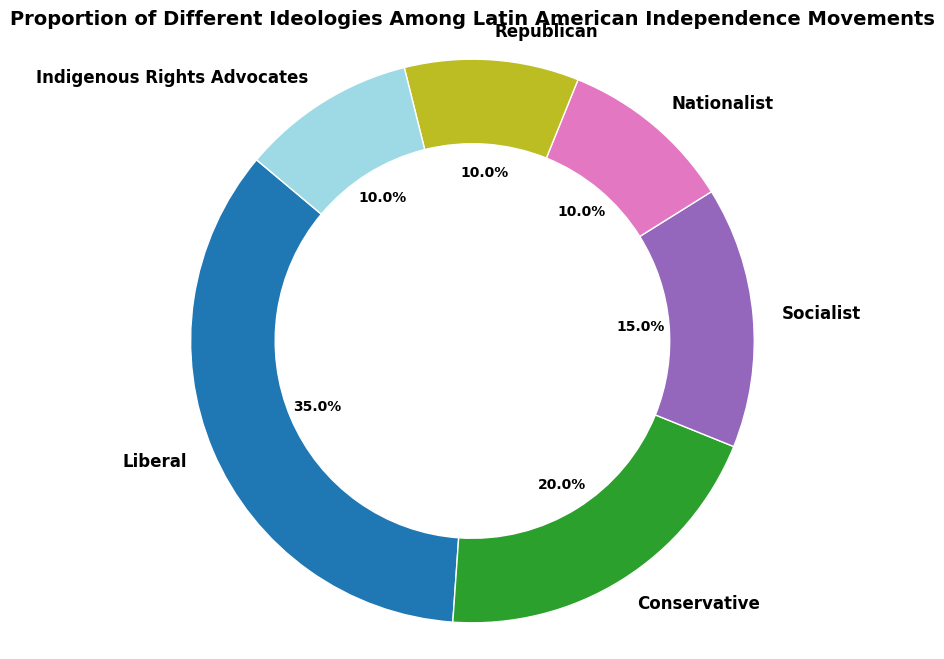What proportion of the ideologies is represented by the Republican and Indigenous Rights Advocates together? Sum the percentages of Republican (10%) and Indigenous Rights Advocates (10%): 10 + 10 = 20
Answer: 20% Which ideology has the largest proportion? The chart shows that the Liberal ideology has the largest slice, labeled as 35%.
Answer: Liberal How does the proportion of Socialists compare to that of Nationalists? The pie chart shows Socialists at 15% and Nationalists at 10%. Therefore, Socialists have a greater proportion.
Answer: Socialists have a greater proportion What is the proportion difference between the highest and the lowest represented ideologies? The highest proportion is Liberal at 35% and the lowest is Nationalist, Republican and Indigenous Rights Advocates each at 10%. The difference is 35 - 10 = 25.
Answer: 25% What are the combined proportions of Liberal, Conservative, and Socialist ideologies? Sum the percentages: Liberal (35%) + Conservative (20%) + Socialist (15%) = 35 + 20 + 15 = 70
Answer: 70% Is the proportion of Nationalists greater than that of Republicans? The pie chart shows both Nationalists and Republicans at 10%. So, neither is greater.
Answer: No Which ideology is represented by the smallest proportion and what is that proportion? The chart shows Nationalists, Republicans, and Indigenous Rights Advocates each at 10%, the smallest proportion.
Answer: Nationalists, Republicans, Indigenous Rights Advocates; 10% If we were to group Conservative and Indigenous Rights Advocates together, what would their combined proportion be? Sum the percentages of Conservative (20%) and Indigenous Rights Advocates (10%): 20 + 10 = 30
Answer: 30% What is the total percentage of ideologies combined other than Liberal? Sum the percentages of all other ideologies: Conservative (20%) + Socialist (15%) + Nationalist (10%) + Republican (10%) + Indigenous Rights Advocates (10%) = 20 + 15 + 10 + 10 + 10 = 65
Answer: 65% What proportion of the total ideologies is made up of ideologies other than Socialist and Indigenous Rights Advocates? Subtract percentages of Socialist (15%) and Indigenous Rights Advocates (10%) from 100: 100 - 15 - 10 = 75
Answer: 75% 